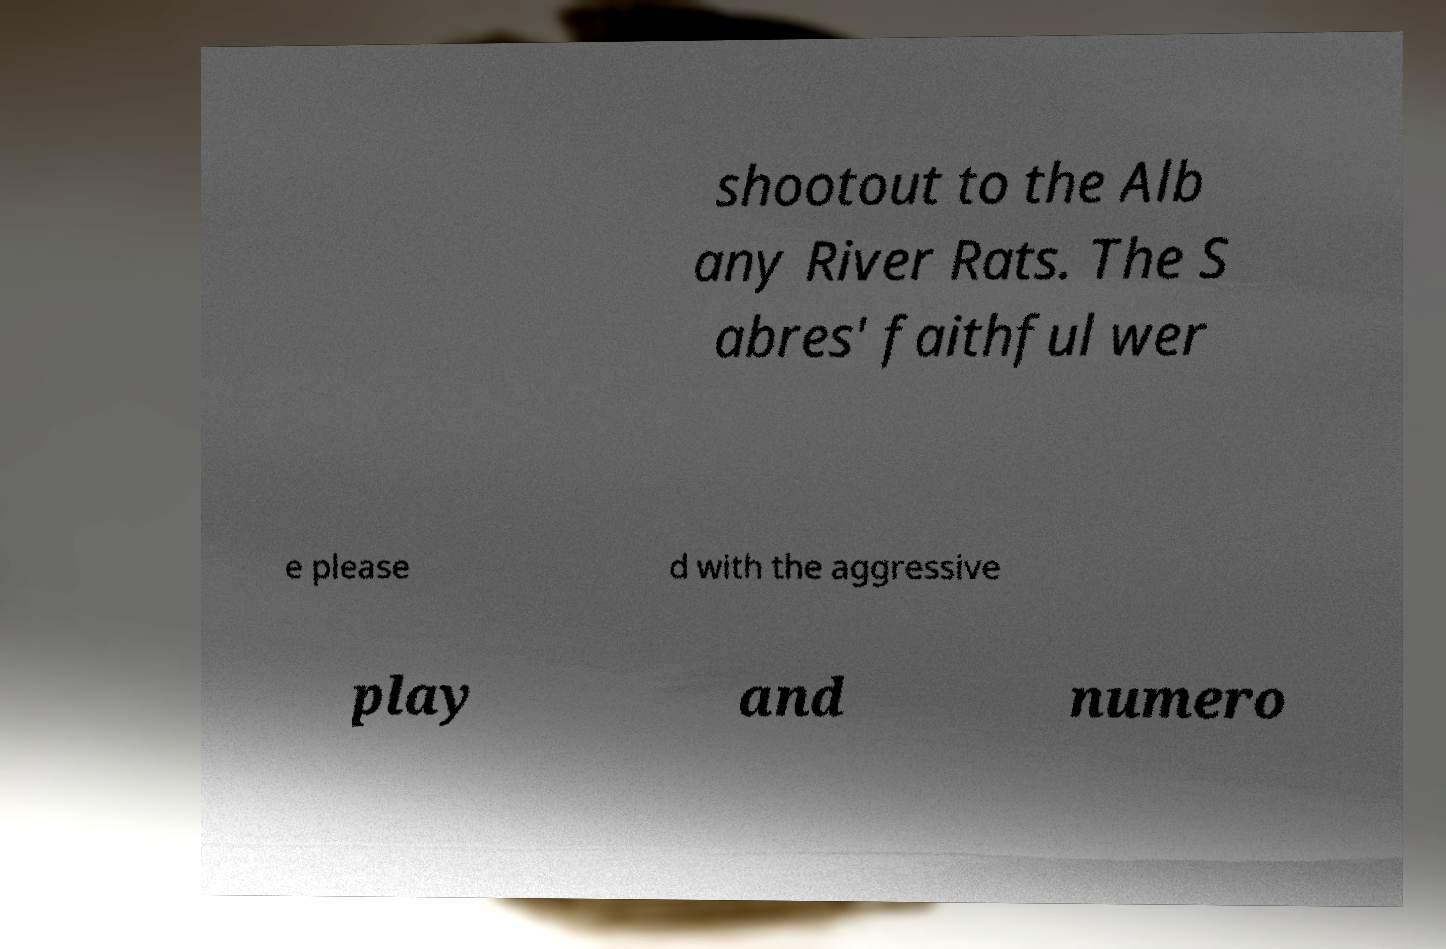Can you read and provide the text displayed in the image?This photo seems to have some interesting text. Can you extract and type it out for me? shootout to the Alb any River Rats. The S abres' faithful wer e please d with the aggressive play and numero 